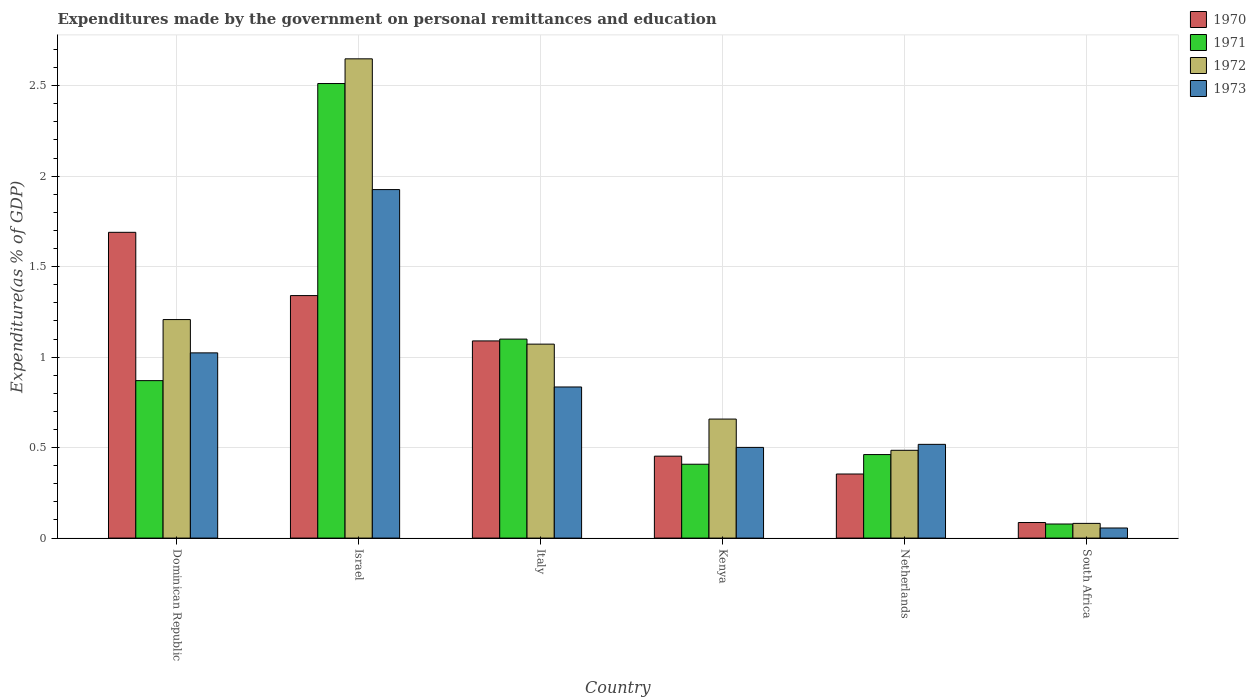Are the number of bars on each tick of the X-axis equal?
Keep it short and to the point. Yes. How many bars are there on the 4th tick from the right?
Provide a short and direct response. 4. What is the label of the 5th group of bars from the left?
Ensure brevity in your answer.  Netherlands. In how many cases, is the number of bars for a given country not equal to the number of legend labels?
Provide a succinct answer. 0. What is the expenditures made by the government on personal remittances and education in 1973 in South Africa?
Make the answer very short. 0.06. Across all countries, what is the maximum expenditures made by the government on personal remittances and education in 1971?
Give a very brief answer. 2.51. Across all countries, what is the minimum expenditures made by the government on personal remittances and education in 1971?
Keep it short and to the point. 0.08. In which country was the expenditures made by the government on personal remittances and education in 1970 maximum?
Provide a short and direct response. Dominican Republic. In which country was the expenditures made by the government on personal remittances and education in 1973 minimum?
Keep it short and to the point. South Africa. What is the total expenditures made by the government on personal remittances and education in 1971 in the graph?
Provide a short and direct response. 5.43. What is the difference between the expenditures made by the government on personal remittances and education in 1971 in Israel and that in Netherlands?
Provide a succinct answer. 2.05. What is the difference between the expenditures made by the government on personal remittances and education in 1971 in Kenya and the expenditures made by the government on personal remittances and education in 1973 in Israel?
Your response must be concise. -1.52. What is the average expenditures made by the government on personal remittances and education in 1973 per country?
Provide a succinct answer. 0.81. What is the difference between the expenditures made by the government on personal remittances and education of/in 1972 and expenditures made by the government on personal remittances and education of/in 1971 in Italy?
Provide a succinct answer. -0.03. In how many countries, is the expenditures made by the government on personal remittances and education in 1971 greater than 2.5 %?
Give a very brief answer. 1. What is the ratio of the expenditures made by the government on personal remittances and education in 1972 in Dominican Republic to that in Netherlands?
Offer a very short reply. 2.49. Is the expenditures made by the government on personal remittances and education in 1971 in Dominican Republic less than that in South Africa?
Provide a short and direct response. No. What is the difference between the highest and the second highest expenditures made by the government on personal remittances and education in 1971?
Your answer should be very brief. -0.23. What is the difference between the highest and the lowest expenditures made by the government on personal remittances and education in 1970?
Keep it short and to the point. 1.6. In how many countries, is the expenditures made by the government on personal remittances and education in 1972 greater than the average expenditures made by the government on personal remittances and education in 1972 taken over all countries?
Ensure brevity in your answer.  3. Is the sum of the expenditures made by the government on personal remittances and education in 1972 in Dominican Republic and Italy greater than the maximum expenditures made by the government on personal remittances and education in 1970 across all countries?
Ensure brevity in your answer.  Yes. Is it the case that in every country, the sum of the expenditures made by the government on personal remittances and education in 1973 and expenditures made by the government on personal remittances and education in 1970 is greater than the sum of expenditures made by the government on personal remittances and education in 1971 and expenditures made by the government on personal remittances and education in 1972?
Your response must be concise. No. What does the 3rd bar from the right in Italy represents?
Offer a very short reply. 1971. Is it the case that in every country, the sum of the expenditures made by the government on personal remittances and education in 1972 and expenditures made by the government on personal remittances and education in 1970 is greater than the expenditures made by the government on personal remittances and education in 1973?
Offer a terse response. Yes. Are the values on the major ticks of Y-axis written in scientific E-notation?
Your response must be concise. No. Does the graph contain any zero values?
Give a very brief answer. No. How many legend labels are there?
Give a very brief answer. 4. How are the legend labels stacked?
Your answer should be very brief. Vertical. What is the title of the graph?
Provide a succinct answer. Expenditures made by the government on personal remittances and education. Does "1972" appear as one of the legend labels in the graph?
Ensure brevity in your answer.  Yes. What is the label or title of the Y-axis?
Offer a terse response. Expenditure(as % of GDP). What is the Expenditure(as % of GDP) in 1970 in Dominican Republic?
Keep it short and to the point. 1.69. What is the Expenditure(as % of GDP) of 1971 in Dominican Republic?
Offer a terse response. 0.87. What is the Expenditure(as % of GDP) of 1972 in Dominican Republic?
Provide a succinct answer. 1.21. What is the Expenditure(as % of GDP) in 1973 in Dominican Republic?
Provide a succinct answer. 1.02. What is the Expenditure(as % of GDP) of 1970 in Israel?
Keep it short and to the point. 1.34. What is the Expenditure(as % of GDP) of 1971 in Israel?
Keep it short and to the point. 2.51. What is the Expenditure(as % of GDP) of 1972 in Israel?
Provide a short and direct response. 2.65. What is the Expenditure(as % of GDP) of 1973 in Israel?
Ensure brevity in your answer.  1.93. What is the Expenditure(as % of GDP) of 1970 in Italy?
Provide a short and direct response. 1.09. What is the Expenditure(as % of GDP) in 1971 in Italy?
Provide a succinct answer. 1.1. What is the Expenditure(as % of GDP) of 1972 in Italy?
Make the answer very short. 1.07. What is the Expenditure(as % of GDP) of 1973 in Italy?
Give a very brief answer. 0.84. What is the Expenditure(as % of GDP) of 1970 in Kenya?
Make the answer very short. 0.45. What is the Expenditure(as % of GDP) in 1971 in Kenya?
Your response must be concise. 0.41. What is the Expenditure(as % of GDP) of 1972 in Kenya?
Ensure brevity in your answer.  0.66. What is the Expenditure(as % of GDP) in 1973 in Kenya?
Make the answer very short. 0.5. What is the Expenditure(as % of GDP) in 1970 in Netherlands?
Ensure brevity in your answer.  0.35. What is the Expenditure(as % of GDP) of 1971 in Netherlands?
Give a very brief answer. 0.46. What is the Expenditure(as % of GDP) of 1972 in Netherlands?
Offer a very short reply. 0.49. What is the Expenditure(as % of GDP) of 1973 in Netherlands?
Offer a very short reply. 0.52. What is the Expenditure(as % of GDP) in 1970 in South Africa?
Offer a very short reply. 0.09. What is the Expenditure(as % of GDP) of 1971 in South Africa?
Ensure brevity in your answer.  0.08. What is the Expenditure(as % of GDP) in 1972 in South Africa?
Your response must be concise. 0.08. What is the Expenditure(as % of GDP) of 1973 in South Africa?
Ensure brevity in your answer.  0.06. Across all countries, what is the maximum Expenditure(as % of GDP) of 1970?
Provide a short and direct response. 1.69. Across all countries, what is the maximum Expenditure(as % of GDP) in 1971?
Your answer should be very brief. 2.51. Across all countries, what is the maximum Expenditure(as % of GDP) of 1972?
Your response must be concise. 2.65. Across all countries, what is the maximum Expenditure(as % of GDP) in 1973?
Ensure brevity in your answer.  1.93. Across all countries, what is the minimum Expenditure(as % of GDP) of 1970?
Provide a short and direct response. 0.09. Across all countries, what is the minimum Expenditure(as % of GDP) of 1971?
Your answer should be compact. 0.08. Across all countries, what is the minimum Expenditure(as % of GDP) of 1972?
Keep it short and to the point. 0.08. Across all countries, what is the minimum Expenditure(as % of GDP) in 1973?
Ensure brevity in your answer.  0.06. What is the total Expenditure(as % of GDP) of 1970 in the graph?
Offer a terse response. 5.01. What is the total Expenditure(as % of GDP) in 1971 in the graph?
Make the answer very short. 5.43. What is the total Expenditure(as % of GDP) in 1972 in the graph?
Offer a very short reply. 6.15. What is the total Expenditure(as % of GDP) of 1973 in the graph?
Your response must be concise. 4.86. What is the difference between the Expenditure(as % of GDP) of 1970 in Dominican Republic and that in Israel?
Provide a succinct answer. 0.35. What is the difference between the Expenditure(as % of GDP) of 1971 in Dominican Republic and that in Israel?
Provide a short and direct response. -1.64. What is the difference between the Expenditure(as % of GDP) of 1972 in Dominican Republic and that in Israel?
Your answer should be very brief. -1.44. What is the difference between the Expenditure(as % of GDP) of 1973 in Dominican Republic and that in Israel?
Provide a succinct answer. -0.9. What is the difference between the Expenditure(as % of GDP) of 1970 in Dominican Republic and that in Italy?
Offer a terse response. 0.6. What is the difference between the Expenditure(as % of GDP) in 1971 in Dominican Republic and that in Italy?
Provide a short and direct response. -0.23. What is the difference between the Expenditure(as % of GDP) in 1972 in Dominican Republic and that in Italy?
Make the answer very short. 0.14. What is the difference between the Expenditure(as % of GDP) of 1973 in Dominican Republic and that in Italy?
Your response must be concise. 0.19. What is the difference between the Expenditure(as % of GDP) of 1970 in Dominican Republic and that in Kenya?
Keep it short and to the point. 1.24. What is the difference between the Expenditure(as % of GDP) of 1971 in Dominican Republic and that in Kenya?
Your answer should be very brief. 0.46. What is the difference between the Expenditure(as % of GDP) of 1972 in Dominican Republic and that in Kenya?
Your response must be concise. 0.55. What is the difference between the Expenditure(as % of GDP) in 1973 in Dominican Republic and that in Kenya?
Ensure brevity in your answer.  0.52. What is the difference between the Expenditure(as % of GDP) in 1970 in Dominican Republic and that in Netherlands?
Offer a very short reply. 1.34. What is the difference between the Expenditure(as % of GDP) of 1971 in Dominican Republic and that in Netherlands?
Offer a terse response. 0.41. What is the difference between the Expenditure(as % of GDP) in 1972 in Dominican Republic and that in Netherlands?
Your answer should be compact. 0.72. What is the difference between the Expenditure(as % of GDP) of 1973 in Dominican Republic and that in Netherlands?
Keep it short and to the point. 0.51. What is the difference between the Expenditure(as % of GDP) of 1970 in Dominican Republic and that in South Africa?
Ensure brevity in your answer.  1.6. What is the difference between the Expenditure(as % of GDP) in 1971 in Dominican Republic and that in South Africa?
Provide a short and direct response. 0.79. What is the difference between the Expenditure(as % of GDP) of 1972 in Dominican Republic and that in South Africa?
Your answer should be compact. 1.13. What is the difference between the Expenditure(as % of GDP) in 1973 in Dominican Republic and that in South Africa?
Your answer should be compact. 0.97. What is the difference between the Expenditure(as % of GDP) of 1970 in Israel and that in Italy?
Make the answer very short. 0.25. What is the difference between the Expenditure(as % of GDP) of 1971 in Israel and that in Italy?
Give a very brief answer. 1.41. What is the difference between the Expenditure(as % of GDP) in 1972 in Israel and that in Italy?
Your answer should be very brief. 1.58. What is the difference between the Expenditure(as % of GDP) in 1973 in Israel and that in Italy?
Offer a very short reply. 1.09. What is the difference between the Expenditure(as % of GDP) of 1970 in Israel and that in Kenya?
Ensure brevity in your answer.  0.89. What is the difference between the Expenditure(as % of GDP) in 1971 in Israel and that in Kenya?
Your answer should be very brief. 2.1. What is the difference between the Expenditure(as % of GDP) of 1972 in Israel and that in Kenya?
Keep it short and to the point. 1.99. What is the difference between the Expenditure(as % of GDP) in 1973 in Israel and that in Kenya?
Your answer should be very brief. 1.42. What is the difference between the Expenditure(as % of GDP) in 1970 in Israel and that in Netherlands?
Offer a very short reply. 0.99. What is the difference between the Expenditure(as % of GDP) of 1971 in Israel and that in Netherlands?
Your answer should be very brief. 2.05. What is the difference between the Expenditure(as % of GDP) of 1972 in Israel and that in Netherlands?
Keep it short and to the point. 2.16. What is the difference between the Expenditure(as % of GDP) in 1973 in Israel and that in Netherlands?
Offer a terse response. 1.41. What is the difference between the Expenditure(as % of GDP) in 1970 in Israel and that in South Africa?
Ensure brevity in your answer.  1.25. What is the difference between the Expenditure(as % of GDP) of 1971 in Israel and that in South Africa?
Keep it short and to the point. 2.43. What is the difference between the Expenditure(as % of GDP) of 1972 in Israel and that in South Africa?
Your answer should be compact. 2.57. What is the difference between the Expenditure(as % of GDP) of 1973 in Israel and that in South Africa?
Make the answer very short. 1.87. What is the difference between the Expenditure(as % of GDP) of 1970 in Italy and that in Kenya?
Offer a very short reply. 0.64. What is the difference between the Expenditure(as % of GDP) of 1971 in Italy and that in Kenya?
Your answer should be very brief. 0.69. What is the difference between the Expenditure(as % of GDP) in 1972 in Italy and that in Kenya?
Your response must be concise. 0.41. What is the difference between the Expenditure(as % of GDP) of 1973 in Italy and that in Kenya?
Provide a succinct answer. 0.33. What is the difference between the Expenditure(as % of GDP) of 1970 in Italy and that in Netherlands?
Your answer should be compact. 0.74. What is the difference between the Expenditure(as % of GDP) of 1971 in Italy and that in Netherlands?
Give a very brief answer. 0.64. What is the difference between the Expenditure(as % of GDP) in 1972 in Italy and that in Netherlands?
Your answer should be compact. 0.59. What is the difference between the Expenditure(as % of GDP) in 1973 in Italy and that in Netherlands?
Provide a succinct answer. 0.32. What is the difference between the Expenditure(as % of GDP) of 1971 in Italy and that in South Africa?
Your response must be concise. 1.02. What is the difference between the Expenditure(as % of GDP) in 1972 in Italy and that in South Africa?
Provide a succinct answer. 0.99. What is the difference between the Expenditure(as % of GDP) of 1973 in Italy and that in South Africa?
Offer a terse response. 0.78. What is the difference between the Expenditure(as % of GDP) in 1970 in Kenya and that in Netherlands?
Your response must be concise. 0.1. What is the difference between the Expenditure(as % of GDP) of 1971 in Kenya and that in Netherlands?
Provide a short and direct response. -0.05. What is the difference between the Expenditure(as % of GDP) of 1972 in Kenya and that in Netherlands?
Make the answer very short. 0.17. What is the difference between the Expenditure(as % of GDP) of 1973 in Kenya and that in Netherlands?
Offer a very short reply. -0.02. What is the difference between the Expenditure(as % of GDP) in 1970 in Kenya and that in South Africa?
Provide a succinct answer. 0.37. What is the difference between the Expenditure(as % of GDP) of 1971 in Kenya and that in South Africa?
Your response must be concise. 0.33. What is the difference between the Expenditure(as % of GDP) in 1972 in Kenya and that in South Africa?
Keep it short and to the point. 0.58. What is the difference between the Expenditure(as % of GDP) in 1973 in Kenya and that in South Africa?
Offer a terse response. 0.45. What is the difference between the Expenditure(as % of GDP) in 1970 in Netherlands and that in South Africa?
Your answer should be compact. 0.27. What is the difference between the Expenditure(as % of GDP) of 1971 in Netherlands and that in South Africa?
Keep it short and to the point. 0.38. What is the difference between the Expenditure(as % of GDP) in 1972 in Netherlands and that in South Africa?
Ensure brevity in your answer.  0.4. What is the difference between the Expenditure(as % of GDP) of 1973 in Netherlands and that in South Africa?
Your response must be concise. 0.46. What is the difference between the Expenditure(as % of GDP) of 1970 in Dominican Republic and the Expenditure(as % of GDP) of 1971 in Israel?
Your answer should be very brief. -0.82. What is the difference between the Expenditure(as % of GDP) in 1970 in Dominican Republic and the Expenditure(as % of GDP) in 1972 in Israel?
Ensure brevity in your answer.  -0.96. What is the difference between the Expenditure(as % of GDP) in 1970 in Dominican Republic and the Expenditure(as % of GDP) in 1973 in Israel?
Offer a very short reply. -0.24. What is the difference between the Expenditure(as % of GDP) in 1971 in Dominican Republic and the Expenditure(as % of GDP) in 1972 in Israel?
Keep it short and to the point. -1.78. What is the difference between the Expenditure(as % of GDP) in 1971 in Dominican Republic and the Expenditure(as % of GDP) in 1973 in Israel?
Your response must be concise. -1.06. What is the difference between the Expenditure(as % of GDP) in 1972 in Dominican Republic and the Expenditure(as % of GDP) in 1973 in Israel?
Your answer should be very brief. -0.72. What is the difference between the Expenditure(as % of GDP) in 1970 in Dominican Republic and the Expenditure(as % of GDP) in 1971 in Italy?
Provide a short and direct response. 0.59. What is the difference between the Expenditure(as % of GDP) of 1970 in Dominican Republic and the Expenditure(as % of GDP) of 1972 in Italy?
Your answer should be very brief. 0.62. What is the difference between the Expenditure(as % of GDP) in 1970 in Dominican Republic and the Expenditure(as % of GDP) in 1973 in Italy?
Offer a very short reply. 0.85. What is the difference between the Expenditure(as % of GDP) of 1971 in Dominican Republic and the Expenditure(as % of GDP) of 1972 in Italy?
Offer a terse response. -0.2. What is the difference between the Expenditure(as % of GDP) in 1971 in Dominican Republic and the Expenditure(as % of GDP) in 1973 in Italy?
Provide a short and direct response. 0.04. What is the difference between the Expenditure(as % of GDP) in 1972 in Dominican Republic and the Expenditure(as % of GDP) in 1973 in Italy?
Provide a succinct answer. 0.37. What is the difference between the Expenditure(as % of GDP) of 1970 in Dominican Republic and the Expenditure(as % of GDP) of 1971 in Kenya?
Provide a succinct answer. 1.28. What is the difference between the Expenditure(as % of GDP) of 1970 in Dominican Republic and the Expenditure(as % of GDP) of 1972 in Kenya?
Make the answer very short. 1.03. What is the difference between the Expenditure(as % of GDP) of 1970 in Dominican Republic and the Expenditure(as % of GDP) of 1973 in Kenya?
Offer a very short reply. 1.19. What is the difference between the Expenditure(as % of GDP) of 1971 in Dominican Republic and the Expenditure(as % of GDP) of 1972 in Kenya?
Keep it short and to the point. 0.21. What is the difference between the Expenditure(as % of GDP) in 1971 in Dominican Republic and the Expenditure(as % of GDP) in 1973 in Kenya?
Give a very brief answer. 0.37. What is the difference between the Expenditure(as % of GDP) of 1972 in Dominican Republic and the Expenditure(as % of GDP) of 1973 in Kenya?
Your answer should be compact. 0.71. What is the difference between the Expenditure(as % of GDP) in 1970 in Dominican Republic and the Expenditure(as % of GDP) in 1971 in Netherlands?
Ensure brevity in your answer.  1.23. What is the difference between the Expenditure(as % of GDP) of 1970 in Dominican Republic and the Expenditure(as % of GDP) of 1972 in Netherlands?
Your answer should be compact. 1.2. What is the difference between the Expenditure(as % of GDP) in 1970 in Dominican Republic and the Expenditure(as % of GDP) in 1973 in Netherlands?
Offer a very short reply. 1.17. What is the difference between the Expenditure(as % of GDP) in 1971 in Dominican Republic and the Expenditure(as % of GDP) in 1972 in Netherlands?
Your answer should be compact. 0.39. What is the difference between the Expenditure(as % of GDP) in 1971 in Dominican Republic and the Expenditure(as % of GDP) in 1973 in Netherlands?
Provide a short and direct response. 0.35. What is the difference between the Expenditure(as % of GDP) in 1972 in Dominican Republic and the Expenditure(as % of GDP) in 1973 in Netherlands?
Your answer should be very brief. 0.69. What is the difference between the Expenditure(as % of GDP) in 1970 in Dominican Republic and the Expenditure(as % of GDP) in 1971 in South Africa?
Offer a terse response. 1.61. What is the difference between the Expenditure(as % of GDP) of 1970 in Dominican Republic and the Expenditure(as % of GDP) of 1972 in South Africa?
Ensure brevity in your answer.  1.61. What is the difference between the Expenditure(as % of GDP) in 1970 in Dominican Republic and the Expenditure(as % of GDP) in 1973 in South Africa?
Make the answer very short. 1.63. What is the difference between the Expenditure(as % of GDP) in 1971 in Dominican Republic and the Expenditure(as % of GDP) in 1972 in South Africa?
Offer a terse response. 0.79. What is the difference between the Expenditure(as % of GDP) in 1971 in Dominican Republic and the Expenditure(as % of GDP) in 1973 in South Africa?
Make the answer very short. 0.81. What is the difference between the Expenditure(as % of GDP) of 1972 in Dominican Republic and the Expenditure(as % of GDP) of 1973 in South Africa?
Offer a very short reply. 1.15. What is the difference between the Expenditure(as % of GDP) of 1970 in Israel and the Expenditure(as % of GDP) of 1971 in Italy?
Offer a terse response. 0.24. What is the difference between the Expenditure(as % of GDP) in 1970 in Israel and the Expenditure(as % of GDP) in 1972 in Italy?
Your answer should be very brief. 0.27. What is the difference between the Expenditure(as % of GDP) in 1970 in Israel and the Expenditure(as % of GDP) in 1973 in Italy?
Provide a succinct answer. 0.51. What is the difference between the Expenditure(as % of GDP) in 1971 in Israel and the Expenditure(as % of GDP) in 1972 in Italy?
Offer a very short reply. 1.44. What is the difference between the Expenditure(as % of GDP) of 1971 in Israel and the Expenditure(as % of GDP) of 1973 in Italy?
Your answer should be very brief. 1.68. What is the difference between the Expenditure(as % of GDP) in 1972 in Israel and the Expenditure(as % of GDP) in 1973 in Italy?
Offer a terse response. 1.81. What is the difference between the Expenditure(as % of GDP) in 1970 in Israel and the Expenditure(as % of GDP) in 1971 in Kenya?
Your answer should be very brief. 0.93. What is the difference between the Expenditure(as % of GDP) in 1970 in Israel and the Expenditure(as % of GDP) in 1972 in Kenya?
Provide a short and direct response. 0.68. What is the difference between the Expenditure(as % of GDP) in 1970 in Israel and the Expenditure(as % of GDP) in 1973 in Kenya?
Give a very brief answer. 0.84. What is the difference between the Expenditure(as % of GDP) in 1971 in Israel and the Expenditure(as % of GDP) in 1972 in Kenya?
Make the answer very short. 1.85. What is the difference between the Expenditure(as % of GDP) in 1971 in Israel and the Expenditure(as % of GDP) in 1973 in Kenya?
Give a very brief answer. 2.01. What is the difference between the Expenditure(as % of GDP) in 1972 in Israel and the Expenditure(as % of GDP) in 1973 in Kenya?
Keep it short and to the point. 2.15. What is the difference between the Expenditure(as % of GDP) in 1970 in Israel and the Expenditure(as % of GDP) in 1971 in Netherlands?
Your response must be concise. 0.88. What is the difference between the Expenditure(as % of GDP) in 1970 in Israel and the Expenditure(as % of GDP) in 1972 in Netherlands?
Ensure brevity in your answer.  0.85. What is the difference between the Expenditure(as % of GDP) in 1970 in Israel and the Expenditure(as % of GDP) in 1973 in Netherlands?
Provide a short and direct response. 0.82. What is the difference between the Expenditure(as % of GDP) of 1971 in Israel and the Expenditure(as % of GDP) of 1972 in Netherlands?
Provide a short and direct response. 2.03. What is the difference between the Expenditure(as % of GDP) of 1971 in Israel and the Expenditure(as % of GDP) of 1973 in Netherlands?
Your answer should be very brief. 1.99. What is the difference between the Expenditure(as % of GDP) in 1972 in Israel and the Expenditure(as % of GDP) in 1973 in Netherlands?
Provide a short and direct response. 2.13. What is the difference between the Expenditure(as % of GDP) of 1970 in Israel and the Expenditure(as % of GDP) of 1971 in South Africa?
Provide a short and direct response. 1.26. What is the difference between the Expenditure(as % of GDP) in 1970 in Israel and the Expenditure(as % of GDP) in 1972 in South Africa?
Your answer should be very brief. 1.26. What is the difference between the Expenditure(as % of GDP) in 1970 in Israel and the Expenditure(as % of GDP) in 1973 in South Africa?
Your response must be concise. 1.28. What is the difference between the Expenditure(as % of GDP) of 1971 in Israel and the Expenditure(as % of GDP) of 1972 in South Africa?
Your answer should be very brief. 2.43. What is the difference between the Expenditure(as % of GDP) in 1971 in Israel and the Expenditure(as % of GDP) in 1973 in South Africa?
Provide a short and direct response. 2.46. What is the difference between the Expenditure(as % of GDP) of 1972 in Israel and the Expenditure(as % of GDP) of 1973 in South Africa?
Keep it short and to the point. 2.59. What is the difference between the Expenditure(as % of GDP) of 1970 in Italy and the Expenditure(as % of GDP) of 1971 in Kenya?
Provide a succinct answer. 0.68. What is the difference between the Expenditure(as % of GDP) of 1970 in Italy and the Expenditure(as % of GDP) of 1972 in Kenya?
Make the answer very short. 0.43. What is the difference between the Expenditure(as % of GDP) in 1970 in Italy and the Expenditure(as % of GDP) in 1973 in Kenya?
Offer a terse response. 0.59. What is the difference between the Expenditure(as % of GDP) of 1971 in Italy and the Expenditure(as % of GDP) of 1972 in Kenya?
Provide a short and direct response. 0.44. What is the difference between the Expenditure(as % of GDP) in 1971 in Italy and the Expenditure(as % of GDP) in 1973 in Kenya?
Offer a very short reply. 0.6. What is the difference between the Expenditure(as % of GDP) of 1972 in Italy and the Expenditure(as % of GDP) of 1973 in Kenya?
Provide a succinct answer. 0.57. What is the difference between the Expenditure(as % of GDP) of 1970 in Italy and the Expenditure(as % of GDP) of 1971 in Netherlands?
Keep it short and to the point. 0.63. What is the difference between the Expenditure(as % of GDP) in 1970 in Italy and the Expenditure(as % of GDP) in 1972 in Netherlands?
Offer a terse response. 0.6. What is the difference between the Expenditure(as % of GDP) in 1970 in Italy and the Expenditure(as % of GDP) in 1973 in Netherlands?
Your response must be concise. 0.57. What is the difference between the Expenditure(as % of GDP) of 1971 in Italy and the Expenditure(as % of GDP) of 1972 in Netherlands?
Give a very brief answer. 0.61. What is the difference between the Expenditure(as % of GDP) of 1971 in Italy and the Expenditure(as % of GDP) of 1973 in Netherlands?
Offer a very short reply. 0.58. What is the difference between the Expenditure(as % of GDP) of 1972 in Italy and the Expenditure(as % of GDP) of 1973 in Netherlands?
Your answer should be compact. 0.55. What is the difference between the Expenditure(as % of GDP) in 1970 in Italy and the Expenditure(as % of GDP) in 1971 in South Africa?
Give a very brief answer. 1.01. What is the difference between the Expenditure(as % of GDP) in 1970 in Italy and the Expenditure(as % of GDP) in 1972 in South Africa?
Give a very brief answer. 1.01. What is the difference between the Expenditure(as % of GDP) in 1970 in Italy and the Expenditure(as % of GDP) in 1973 in South Africa?
Ensure brevity in your answer.  1.03. What is the difference between the Expenditure(as % of GDP) in 1971 in Italy and the Expenditure(as % of GDP) in 1972 in South Africa?
Your answer should be compact. 1.02. What is the difference between the Expenditure(as % of GDP) in 1971 in Italy and the Expenditure(as % of GDP) in 1973 in South Africa?
Provide a succinct answer. 1.04. What is the difference between the Expenditure(as % of GDP) of 1970 in Kenya and the Expenditure(as % of GDP) of 1971 in Netherlands?
Ensure brevity in your answer.  -0.01. What is the difference between the Expenditure(as % of GDP) of 1970 in Kenya and the Expenditure(as % of GDP) of 1972 in Netherlands?
Offer a terse response. -0.03. What is the difference between the Expenditure(as % of GDP) in 1970 in Kenya and the Expenditure(as % of GDP) in 1973 in Netherlands?
Your answer should be compact. -0.07. What is the difference between the Expenditure(as % of GDP) in 1971 in Kenya and the Expenditure(as % of GDP) in 1972 in Netherlands?
Provide a succinct answer. -0.08. What is the difference between the Expenditure(as % of GDP) of 1971 in Kenya and the Expenditure(as % of GDP) of 1973 in Netherlands?
Your answer should be compact. -0.11. What is the difference between the Expenditure(as % of GDP) of 1972 in Kenya and the Expenditure(as % of GDP) of 1973 in Netherlands?
Offer a very short reply. 0.14. What is the difference between the Expenditure(as % of GDP) in 1970 in Kenya and the Expenditure(as % of GDP) in 1971 in South Africa?
Offer a terse response. 0.38. What is the difference between the Expenditure(as % of GDP) of 1970 in Kenya and the Expenditure(as % of GDP) of 1972 in South Africa?
Keep it short and to the point. 0.37. What is the difference between the Expenditure(as % of GDP) of 1970 in Kenya and the Expenditure(as % of GDP) of 1973 in South Africa?
Provide a short and direct response. 0.4. What is the difference between the Expenditure(as % of GDP) in 1971 in Kenya and the Expenditure(as % of GDP) in 1972 in South Africa?
Give a very brief answer. 0.33. What is the difference between the Expenditure(as % of GDP) of 1971 in Kenya and the Expenditure(as % of GDP) of 1973 in South Africa?
Provide a short and direct response. 0.35. What is the difference between the Expenditure(as % of GDP) in 1972 in Kenya and the Expenditure(as % of GDP) in 1973 in South Africa?
Your response must be concise. 0.6. What is the difference between the Expenditure(as % of GDP) in 1970 in Netherlands and the Expenditure(as % of GDP) in 1971 in South Africa?
Your answer should be very brief. 0.28. What is the difference between the Expenditure(as % of GDP) of 1970 in Netherlands and the Expenditure(as % of GDP) of 1972 in South Africa?
Offer a terse response. 0.27. What is the difference between the Expenditure(as % of GDP) of 1970 in Netherlands and the Expenditure(as % of GDP) of 1973 in South Africa?
Keep it short and to the point. 0.3. What is the difference between the Expenditure(as % of GDP) of 1971 in Netherlands and the Expenditure(as % of GDP) of 1972 in South Africa?
Offer a terse response. 0.38. What is the difference between the Expenditure(as % of GDP) in 1971 in Netherlands and the Expenditure(as % of GDP) in 1973 in South Africa?
Provide a short and direct response. 0.41. What is the difference between the Expenditure(as % of GDP) of 1972 in Netherlands and the Expenditure(as % of GDP) of 1973 in South Africa?
Your answer should be very brief. 0.43. What is the average Expenditure(as % of GDP) of 1970 per country?
Make the answer very short. 0.84. What is the average Expenditure(as % of GDP) in 1971 per country?
Offer a very short reply. 0.9. What is the average Expenditure(as % of GDP) of 1972 per country?
Give a very brief answer. 1.03. What is the average Expenditure(as % of GDP) in 1973 per country?
Provide a short and direct response. 0.81. What is the difference between the Expenditure(as % of GDP) in 1970 and Expenditure(as % of GDP) in 1971 in Dominican Republic?
Your answer should be very brief. 0.82. What is the difference between the Expenditure(as % of GDP) of 1970 and Expenditure(as % of GDP) of 1972 in Dominican Republic?
Make the answer very short. 0.48. What is the difference between the Expenditure(as % of GDP) of 1970 and Expenditure(as % of GDP) of 1973 in Dominican Republic?
Make the answer very short. 0.67. What is the difference between the Expenditure(as % of GDP) of 1971 and Expenditure(as % of GDP) of 1972 in Dominican Republic?
Give a very brief answer. -0.34. What is the difference between the Expenditure(as % of GDP) of 1971 and Expenditure(as % of GDP) of 1973 in Dominican Republic?
Your response must be concise. -0.15. What is the difference between the Expenditure(as % of GDP) in 1972 and Expenditure(as % of GDP) in 1973 in Dominican Republic?
Offer a terse response. 0.18. What is the difference between the Expenditure(as % of GDP) in 1970 and Expenditure(as % of GDP) in 1971 in Israel?
Your response must be concise. -1.17. What is the difference between the Expenditure(as % of GDP) of 1970 and Expenditure(as % of GDP) of 1972 in Israel?
Offer a terse response. -1.31. What is the difference between the Expenditure(as % of GDP) of 1970 and Expenditure(as % of GDP) of 1973 in Israel?
Give a very brief answer. -0.59. What is the difference between the Expenditure(as % of GDP) in 1971 and Expenditure(as % of GDP) in 1972 in Israel?
Offer a terse response. -0.14. What is the difference between the Expenditure(as % of GDP) in 1971 and Expenditure(as % of GDP) in 1973 in Israel?
Keep it short and to the point. 0.59. What is the difference between the Expenditure(as % of GDP) of 1972 and Expenditure(as % of GDP) of 1973 in Israel?
Offer a very short reply. 0.72. What is the difference between the Expenditure(as % of GDP) of 1970 and Expenditure(as % of GDP) of 1971 in Italy?
Your answer should be very brief. -0.01. What is the difference between the Expenditure(as % of GDP) in 1970 and Expenditure(as % of GDP) in 1972 in Italy?
Make the answer very short. 0.02. What is the difference between the Expenditure(as % of GDP) in 1970 and Expenditure(as % of GDP) in 1973 in Italy?
Your answer should be very brief. 0.25. What is the difference between the Expenditure(as % of GDP) of 1971 and Expenditure(as % of GDP) of 1972 in Italy?
Your response must be concise. 0.03. What is the difference between the Expenditure(as % of GDP) of 1971 and Expenditure(as % of GDP) of 1973 in Italy?
Offer a terse response. 0.26. What is the difference between the Expenditure(as % of GDP) of 1972 and Expenditure(as % of GDP) of 1973 in Italy?
Ensure brevity in your answer.  0.24. What is the difference between the Expenditure(as % of GDP) of 1970 and Expenditure(as % of GDP) of 1971 in Kenya?
Your response must be concise. 0.04. What is the difference between the Expenditure(as % of GDP) in 1970 and Expenditure(as % of GDP) in 1972 in Kenya?
Provide a succinct answer. -0.2. What is the difference between the Expenditure(as % of GDP) in 1970 and Expenditure(as % of GDP) in 1973 in Kenya?
Offer a very short reply. -0.05. What is the difference between the Expenditure(as % of GDP) of 1971 and Expenditure(as % of GDP) of 1972 in Kenya?
Make the answer very short. -0.25. What is the difference between the Expenditure(as % of GDP) in 1971 and Expenditure(as % of GDP) in 1973 in Kenya?
Keep it short and to the point. -0.09. What is the difference between the Expenditure(as % of GDP) in 1972 and Expenditure(as % of GDP) in 1973 in Kenya?
Ensure brevity in your answer.  0.16. What is the difference between the Expenditure(as % of GDP) of 1970 and Expenditure(as % of GDP) of 1971 in Netherlands?
Make the answer very short. -0.11. What is the difference between the Expenditure(as % of GDP) of 1970 and Expenditure(as % of GDP) of 1972 in Netherlands?
Offer a terse response. -0.13. What is the difference between the Expenditure(as % of GDP) of 1970 and Expenditure(as % of GDP) of 1973 in Netherlands?
Your answer should be very brief. -0.16. What is the difference between the Expenditure(as % of GDP) in 1971 and Expenditure(as % of GDP) in 1972 in Netherlands?
Your response must be concise. -0.02. What is the difference between the Expenditure(as % of GDP) in 1971 and Expenditure(as % of GDP) in 1973 in Netherlands?
Give a very brief answer. -0.06. What is the difference between the Expenditure(as % of GDP) in 1972 and Expenditure(as % of GDP) in 1973 in Netherlands?
Offer a terse response. -0.03. What is the difference between the Expenditure(as % of GDP) of 1970 and Expenditure(as % of GDP) of 1971 in South Africa?
Give a very brief answer. 0.01. What is the difference between the Expenditure(as % of GDP) in 1970 and Expenditure(as % of GDP) in 1972 in South Africa?
Provide a short and direct response. 0. What is the difference between the Expenditure(as % of GDP) of 1970 and Expenditure(as % of GDP) of 1973 in South Africa?
Give a very brief answer. 0.03. What is the difference between the Expenditure(as % of GDP) in 1971 and Expenditure(as % of GDP) in 1972 in South Africa?
Your answer should be very brief. -0. What is the difference between the Expenditure(as % of GDP) in 1971 and Expenditure(as % of GDP) in 1973 in South Africa?
Give a very brief answer. 0.02. What is the difference between the Expenditure(as % of GDP) of 1972 and Expenditure(as % of GDP) of 1973 in South Africa?
Provide a short and direct response. 0.03. What is the ratio of the Expenditure(as % of GDP) of 1970 in Dominican Republic to that in Israel?
Your answer should be very brief. 1.26. What is the ratio of the Expenditure(as % of GDP) of 1971 in Dominican Republic to that in Israel?
Make the answer very short. 0.35. What is the ratio of the Expenditure(as % of GDP) in 1972 in Dominican Republic to that in Israel?
Ensure brevity in your answer.  0.46. What is the ratio of the Expenditure(as % of GDP) in 1973 in Dominican Republic to that in Israel?
Provide a succinct answer. 0.53. What is the ratio of the Expenditure(as % of GDP) of 1970 in Dominican Republic to that in Italy?
Provide a succinct answer. 1.55. What is the ratio of the Expenditure(as % of GDP) of 1971 in Dominican Republic to that in Italy?
Keep it short and to the point. 0.79. What is the ratio of the Expenditure(as % of GDP) of 1972 in Dominican Republic to that in Italy?
Provide a succinct answer. 1.13. What is the ratio of the Expenditure(as % of GDP) of 1973 in Dominican Republic to that in Italy?
Make the answer very short. 1.23. What is the ratio of the Expenditure(as % of GDP) in 1970 in Dominican Republic to that in Kenya?
Offer a very short reply. 3.73. What is the ratio of the Expenditure(as % of GDP) of 1971 in Dominican Republic to that in Kenya?
Make the answer very short. 2.13. What is the ratio of the Expenditure(as % of GDP) of 1972 in Dominican Republic to that in Kenya?
Your answer should be compact. 1.84. What is the ratio of the Expenditure(as % of GDP) in 1973 in Dominican Republic to that in Kenya?
Your response must be concise. 2.04. What is the ratio of the Expenditure(as % of GDP) of 1970 in Dominican Republic to that in Netherlands?
Your answer should be compact. 4.77. What is the ratio of the Expenditure(as % of GDP) of 1971 in Dominican Republic to that in Netherlands?
Your response must be concise. 1.89. What is the ratio of the Expenditure(as % of GDP) of 1972 in Dominican Republic to that in Netherlands?
Your answer should be compact. 2.49. What is the ratio of the Expenditure(as % of GDP) in 1973 in Dominican Republic to that in Netherlands?
Offer a terse response. 1.98. What is the ratio of the Expenditure(as % of GDP) in 1970 in Dominican Republic to that in South Africa?
Make the answer very short. 19.65. What is the ratio of the Expenditure(as % of GDP) of 1971 in Dominican Republic to that in South Africa?
Offer a very short reply. 11.18. What is the ratio of the Expenditure(as % of GDP) of 1972 in Dominican Republic to that in South Africa?
Make the answer very short. 14.85. What is the ratio of the Expenditure(as % of GDP) of 1973 in Dominican Republic to that in South Africa?
Provide a succinct answer. 18.34. What is the ratio of the Expenditure(as % of GDP) of 1970 in Israel to that in Italy?
Make the answer very short. 1.23. What is the ratio of the Expenditure(as % of GDP) of 1971 in Israel to that in Italy?
Provide a succinct answer. 2.28. What is the ratio of the Expenditure(as % of GDP) in 1972 in Israel to that in Italy?
Provide a short and direct response. 2.47. What is the ratio of the Expenditure(as % of GDP) in 1973 in Israel to that in Italy?
Your answer should be compact. 2.31. What is the ratio of the Expenditure(as % of GDP) in 1970 in Israel to that in Kenya?
Give a very brief answer. 2.96. What is the ratio of the Expenditure(as % of GDP) of 1971 in Israel to that in Kenya?
Your response must be concise. 6.15. What is the ratio of the Expenditure(as % of GDP) in 1972 in Israel to that in Kenya?
Ensure brevity in your answer.  4.03. What is the ratio of the Expenditure(as % of GDP) of 1973 in Israel to that in Kenya?
Provide a succinct answer. 3.84. What is the ratio of the Expenditure(as % of GDP) in 1970 in Israel to that in Netherlands?
Provide a short and direct response. 3.78. What is the ratio of the Expenditure(as % of GDP) of 1971 in Israel to that in Netherlands?
Make the answer very short. 5.44. What is the ratio of the Expenditure(as % of GDP) in 1972 in Israel to that in Netherlands?
Provide a short and direct response. 5.46. What is the ratio of the Expenditure(as % of GDP) of 1973 in Israel to that in Netherlands?
Offer a terse response. 3.72. What is the ratio of the Expenditure(as % of GDP) in 1970 in Israel to that in South Africa?
Your answer should be compact. 15.58. What is the ratio of the Expenditure(as % of GDP) in 1971 in Israel to that in South Africa?
Offer a very short reply. 32.29. What is the ratio of the Expenditure(as % of GDP) of 1972 in Israel to that in South Africa?
Keep it short and to the point. 32.58. What is the ratio of the Expenditure(as % of GDP) of 1973 in Israel to that in South Africa?
Offer a very short reply. 34.5. What is the ratio of the Expenditure(as % of GDP) of 1970 in Italy to that in Kenya?
Keep it short and to the point. 2.41. What is the ratio of the Expenditure(as % of GDP) in 1971 in Italy to that in Kenya?
Make the answer very short. 2.69. What is the ratio of the Expenditure(as % of GDP) of 1972 in Italy to that in Kenya?
Your response must be concise. 1.63. What is the ratio of the Expenditure(as % of GDP) in 1973 in Italy to that in Kenya?
Your response must be concise. 1.67. What is the ratio of the Expenditure(as % of GDP) in 1970 in Italy to that in Netherlands?
Offer a terse response. 3.08. What is the ratio of the Expenditure(as % of GDP) of 1971 in Italy to that in Netherlands?
Your answer should be very brief. 2.38. What is the ratio of the Expenditure(as % of GDP) of 1972 in Italy to that in Netherlands?
Provide a succinct answer. 2.21. What is the ratio of the Expenditure(as % of GDP) of 1973 in Italy to that in Netherlands?
Offer a very short reply. 1.61. What is the ratio of the Expenditure(as % of GDP) in 1970 in Italy to that in South Africa?
Give a very brief answer. 12.67. What is the ratio of the Expenditure(as % of GDP) of 1971 in Italy to that in South Africa?
Your response must be concise. 14.13. What is the ratio of the Expenditure(as % of GDP) in 1972 in Italy to that in South Africa?
Give a very brief answer. 13.18. What is the ratio of the Expenditure(as % of GDP) of 1973 in Italy to that in South Africa?
Your response must be concise. 14.96. What is the ratio of the Expenditure(as % of GDP) in 1970 in Kenya to that in Netherlands?
Give a very brief answer. 1.28. What is the ratio of the Expenditure(as % of GDP) of 1971 in Kenya to that in Netherlands?
Keep it short and to the point. 0.88. What is the ratio of the Expenditure(as % of GDP) of 1972 in Kenya to that in Netherlands?
Offer a very short reply. 1.36. What is the ratio of the Expenditure(as % of GDP) in 1973 in Kenya to that in Netherlands?
Your answer should be very brief. 0.97. What is the ratio of the Expenditure(as % of GDP) of 1970 in Kenya to that in South Africa?
Your answer should be compact. 5.26. What is the ratio of the Expenditure(as % of GDP) in 1971 in Kenya to that in South Africa?
Your response must be concise. 5.25. What is the ratio of the Expenditure(as % of GDP) of 1972 in Kenya to that in South Africa?
Provide a short and direct response. 8.09. What is the ratio of the Expenditure(as % of GDP) of 1973 in Kenya to that in South Africa?
Give a very brief answer. 8.98. What is the ratio of the Expenditure(as % of GDP) of 1970 in Netherlands to that in South Africa?
Your answer should be compact. 4.12. What is the ratio of the Expenditure(as % of GDP) of 1971 in Netherlands to that in South Africa?
Provide a succinct answer. 5.93. What is the ratio of the Expenditure(as % of GDP) of 1972 in Netherlands to that in South Africa?
Give a very brief answer. 5.97. What is the ratio of the Expenditure(as % of GDP) of 1973 in Netherlands to that in South Africa?
Offer a terse response. 9.28. What is the difference between the highest and the second highest Expenditure(as % of GDP) in 1970?
Ensure brevity in your answer.  0.35. What is the difference between the highest and the second highest Expenditure(as % of GDP) in 1971?
Offer a terse response. 1.41. What is the difference between the highest and the second highest Expenditure(as % of GDP) in 1972?
Provide a succinct answer. 1.44. What is the difference between the highest and the second highest Expenditure(as % of GDP) in 1973?
Provide a succinct answer. 0.9. What is the difference between the highest and the lowest Expenditure(as % of GDP) of 1970?
Keep it short and to the point. 1.6. What is the difference between the highest and the lowest Expenditure(as % of GDP) of 1971?
Make the answer very short. 2.43. What is the difference between the highest and the lowest Expenditure(as % of GDP) of 1972?
Provide a succinct answer. 2.57. What is the difference between the highest and the lowest Expenditure(as % of GDP) in 1973?
Your answer should be compact. 1.87. 